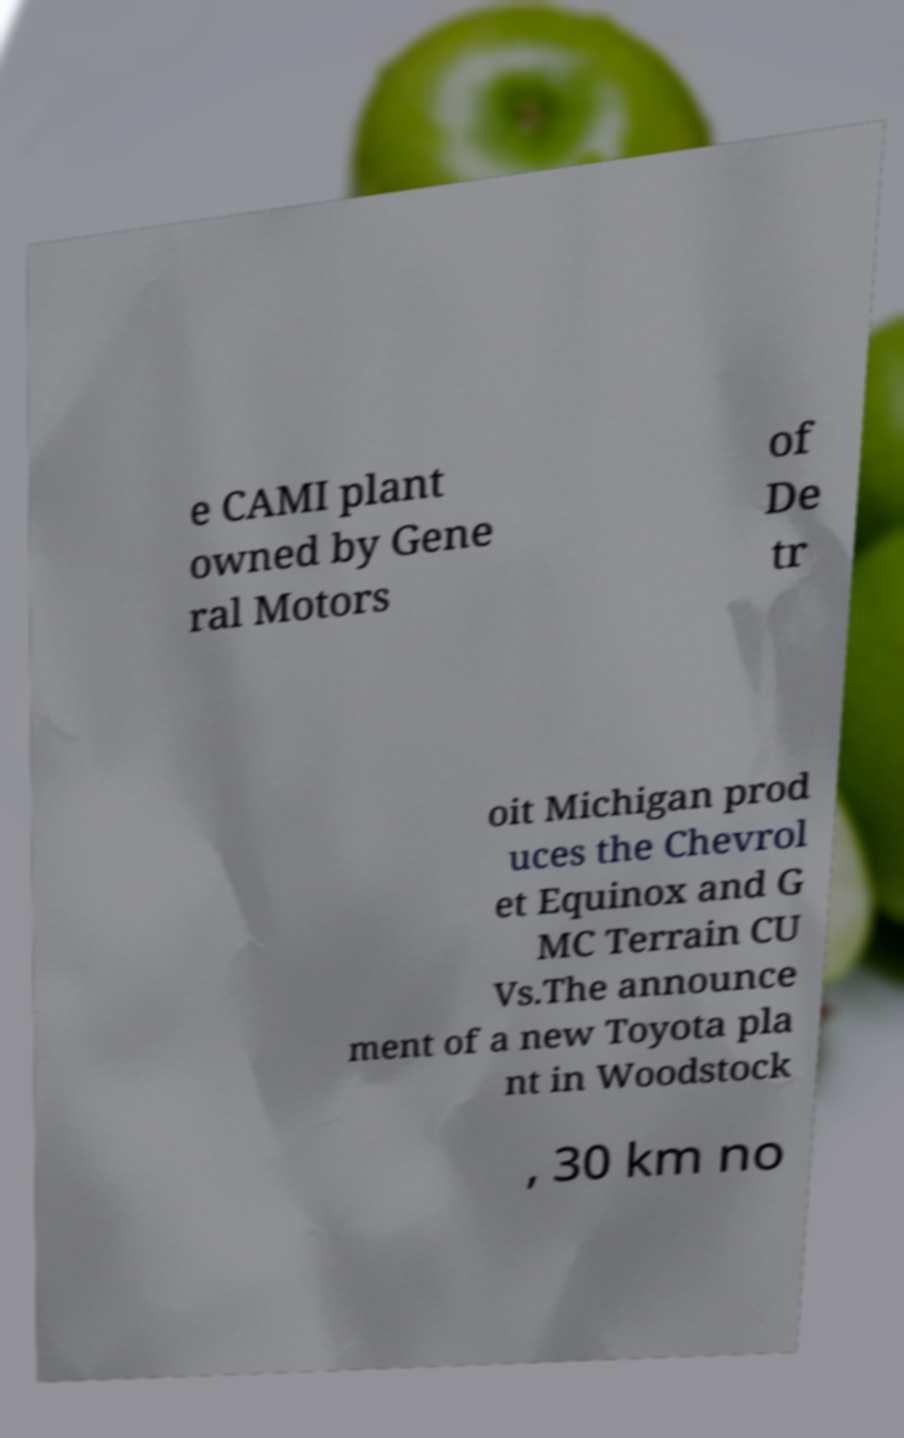Can you accurately transcribe the text from the provided image for me? e CAMI plant owned by Gene ral Motors of De tr oit Michigan prod uces the Chevrol et Equinox and G MC Terrain CU Vs.The announce ment of a new Toyota pla nt in Woodstock , 30 km no 